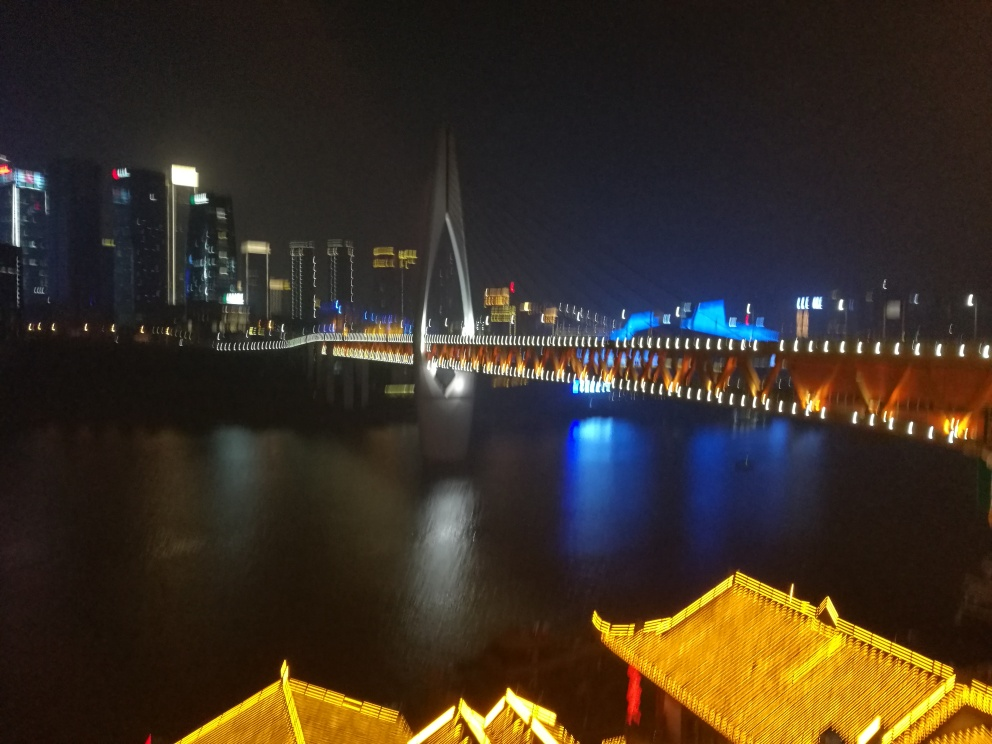What time of day does this image seem to capture? The image appears to have been captured during nighttime. This is indicated by the illuminated lights on the buildings and bridge, and the overall darkness of the sky and water. 